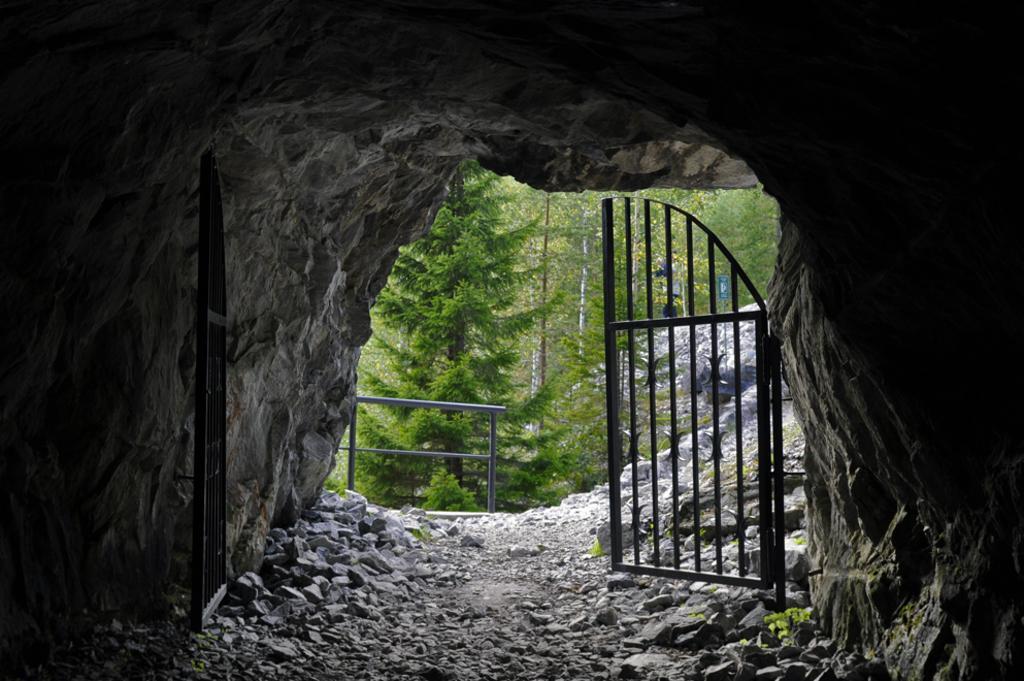Could you give a brief overview of what you see in this image? In this image we can see a cave, stones, iron grill and trees. 